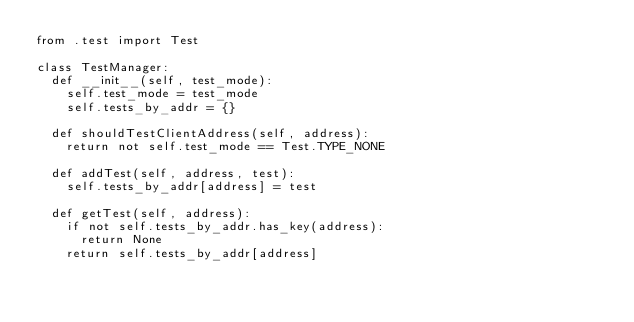Convert code to text. <code><loc_0><loc_0><loc_500><loc_500><_Python_>from .test import Test

class TestManager:
  def __init__(self, test_mode):
    self.test_mode = test_mode
    self.tests_by_addr = {}  

  def shouldTestClientAddress(self, address):
    return not self.test_mode == Test.TYPE_NONE

  def addTest(self, address, test):
    self.tests_by_addr[address] = test

  def getTest(self, address):
    if not self.tests_by_addr.has_key(address):
      return None
    return self.tests_by_addr[address]

</code> 